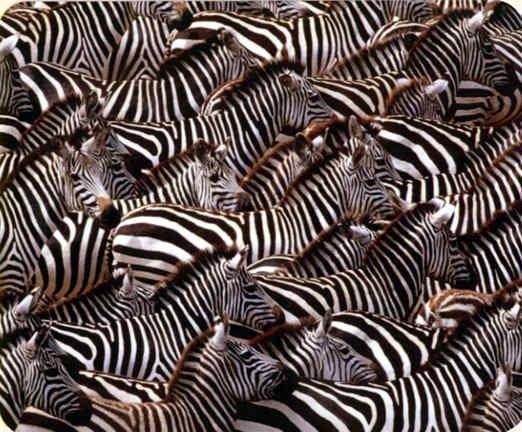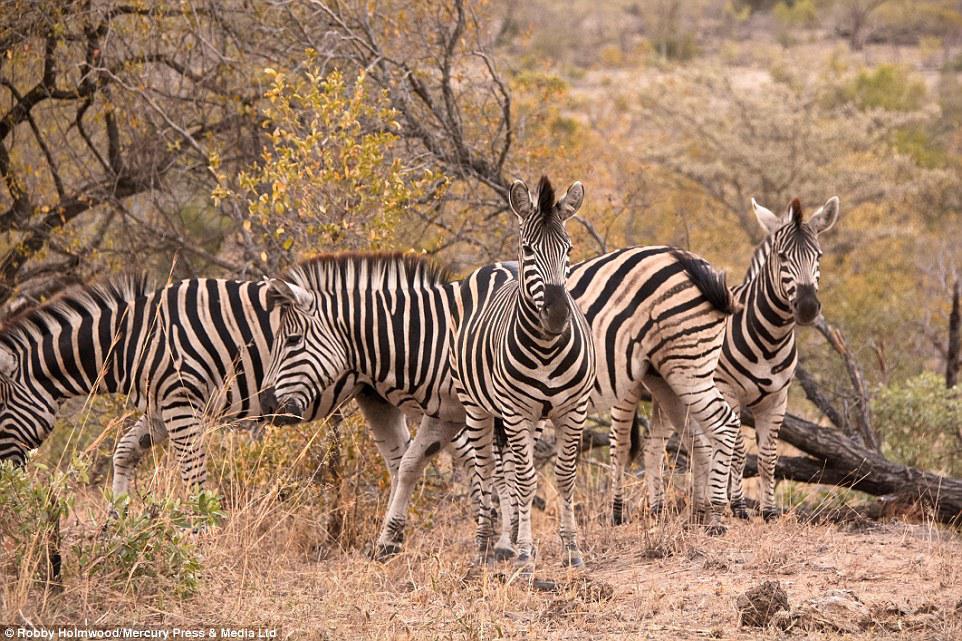The first image is the image on the left, the second image is the image on the right. Assess this claim about the two images: "There are two to three zebra facing left moving forward.". Correct or not? Answer yes or no. No. The first image is the image on the left, the second image is the image on the right. Examine the images to the left and right. Is the description "One image shows a mass of rightward-facing zebras with no space visible between any of them." accurate? Answer yes or no. Yes. 